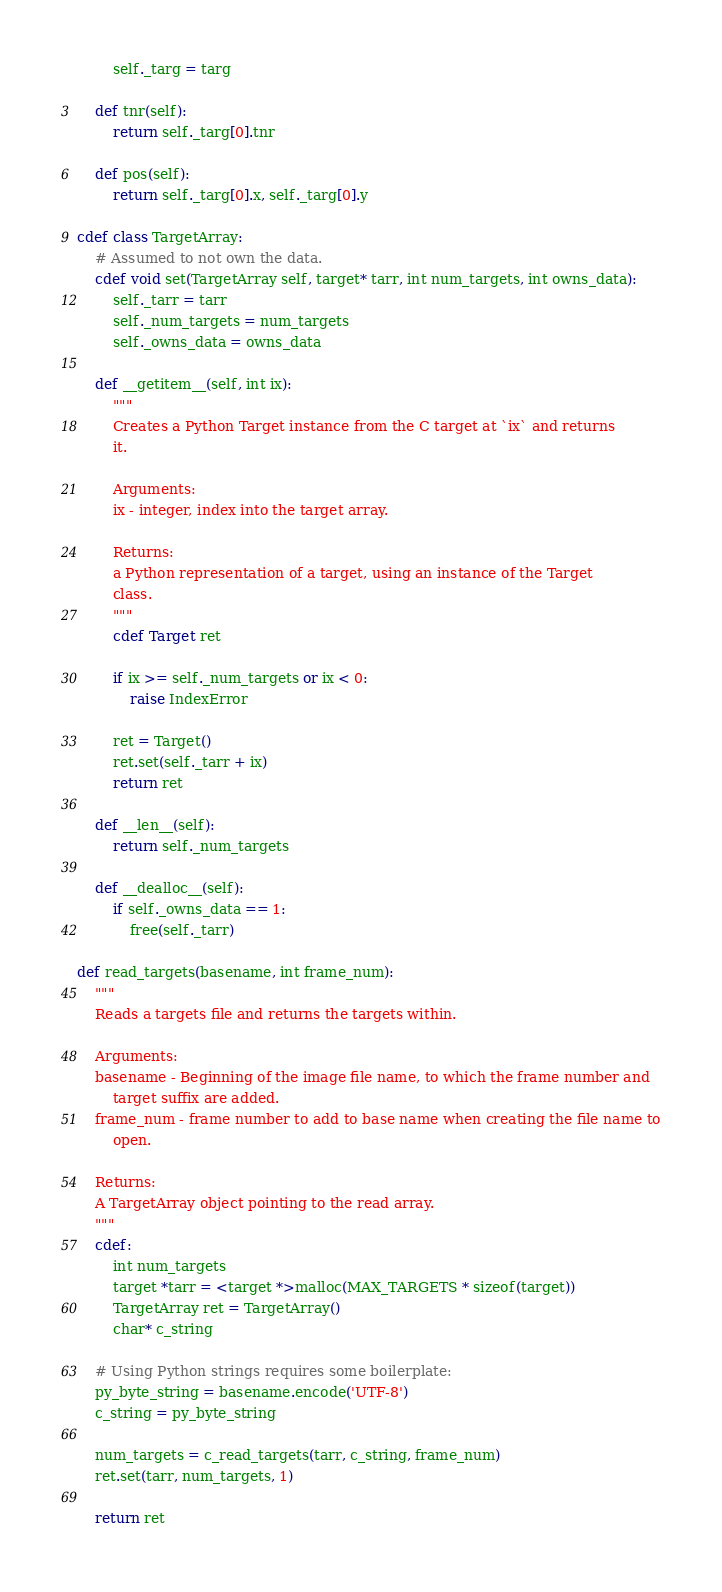Convert code to text. <code><loc_0><loc_0><loc_500><loc_500><_Cython_>        self._targ = targ
    
    def tnr(self):
        return self._targ[0].tnr
    
    def pos(self):
        return self._targ[0].x, self._targ[0].y

cdef class TargetArray:
    # Assumed to not own the data.
    cdef void set(TargetArray self, target* tarr, int num_targets, int owns_data):
        self._tarr = tarr
        self._num_targets = num_targets
        self._owns_data = owns_data
    
    def __getitem__(self, int ix):
        """
        Creates a Python Target instance from the C target at `ix` and returns
        it.
        
        Arguments:
        ix - integer, index into the target array.
        
        Returns:
        a Python representation of a target, using an instance of the Target
        class.
        """
        cdef Target ret
        
        if ix >= self._num_targets or ix < 0:
            raise IndexError
        
        ret = Target()
        ret.set(self._tarr + ix)
        return ret
    
    def __len__(self):
        return self._num_targets
    
    def __dealloc__(self):
        if self._owns_data == 1:
            free(self._tarr)
    
def read_targets(basename, int frame_num):
    """
    Reads a targets file and returns the targets within.
    
    Arguments:
    basename - Beginning of the image file name, to which the frame number and
        target suffix are added.
    frame_num - frame number to add to base name when creating the file name to
        open.
    
    Returns:
    A TargetArray object pointing to the read array.
    """
    cdef:
        int num_targets
        target *tarr = <target *>malloc(MAX_TARGETS * sizeof(target))
        TargetArray ret = TargetArray()
        char* c_string
    
    # Using Python strings requires some boilerplate:
    py_byte_string = basename.encode('UTF-8')
    c_string = py_byte_string
    
    num_targets = c_read_targets(tarr, c_string, frame_num)
    ret.set(tarr, num_targets, 1)
    
    return ret

</code> 